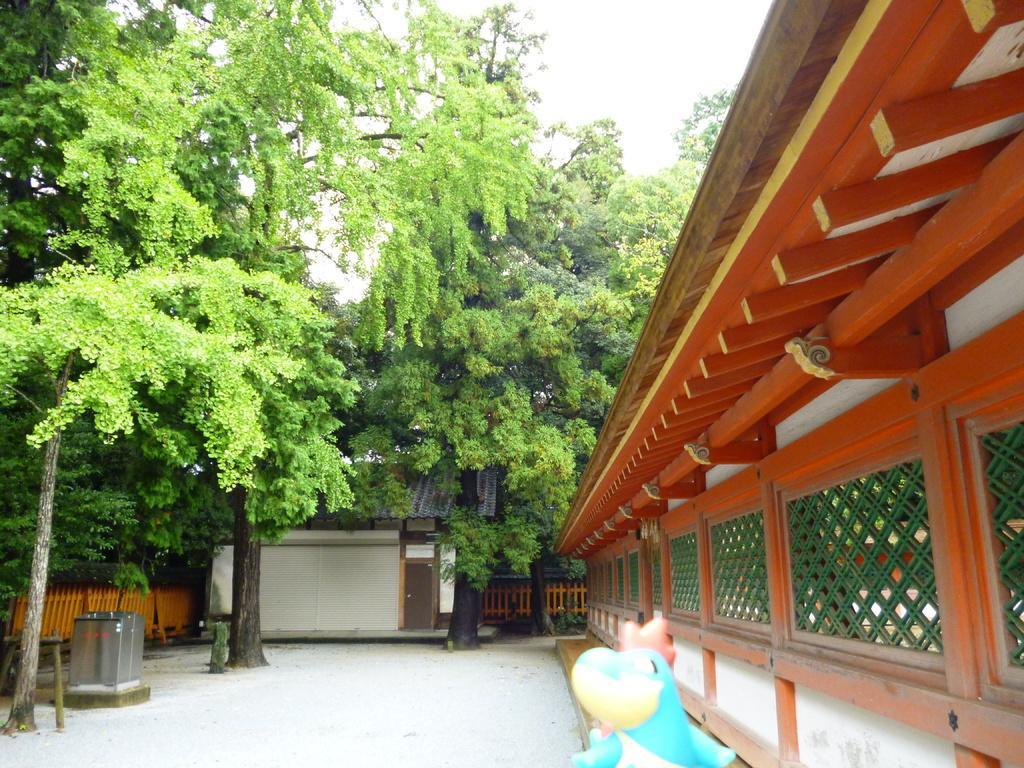Can you describe this image briefly? In this image I can see few trees, few buildings and here I can see a blue colour thing. 